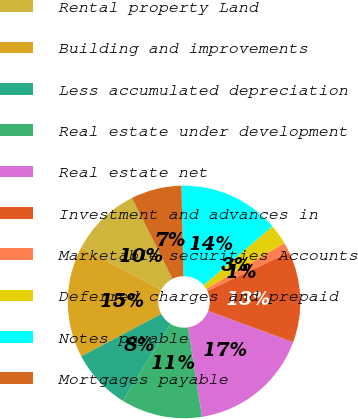Convert chart. <chart><loc_0><loc_0><loc_500><loc_500><pie_chart><fcel>Rental property Land<fcel>Building and improvements<fcel>Less accumulated depreciation<fcel>Real estate under development<fcel>Real estate net<fcel>Investment and advances in<fcel>Marketable securities Accounts<fcel>Deferred charges and prepaid<fcel>Notes payable<fcel>Mortgages payable<nl><fcel>9.86%<fcel>15.49%<fcel>8.45%<fcel>11.27%<fcel>16.9%<fcel>12.68%<fcel>1.41%<fcel>2.82%<fcel>14.08%<fcel>7.04%<nl></chart> 